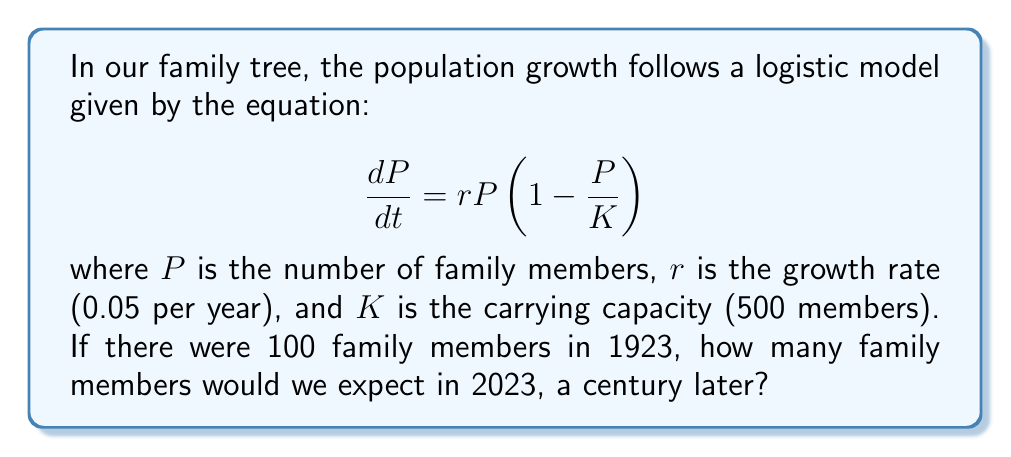Could you help me with this problem? To solve this problem, we need to use the solution to the logistic equation:

1. The solution to the logistic equation is:

   $$P(t) = \frac{K}{1 + (\frac{K}{P_0} - 1)e^{-rt}}$$

   where $P_0$ is the initial population.

2. We are given:
   - $K = 500$ (carrying capacity)
   - $r = 0.05$ (growth rate per year)
   - $P_0 = 100$ (initial population in 1923)
   - $t = 100$ (time elapsed in years)

3. Let's substitute these values into the equation:

   $$P(100) = \frac{500}{1 + (\frac{500}{100} - 1)e^{-0.05 \cdot 100}}$$

4. Simplify:
   $$P(100) = \frac{500}{1 + 4e^{-5}}$$

5. Calculate $e^{-5} \approx 0.00674$

6. Substitute this value:
   $$P(100) = \frac{500}{1 + 4(0.00674)} \approx \frac{500}{1.02696}$$

7. Calculate the final result:
   $$P(100) \approx 486.87$$

8. Since we're dealing with people, we round to the nearest whole number:
   $$P(100) \approx 487$$
Answer: 487 family members 